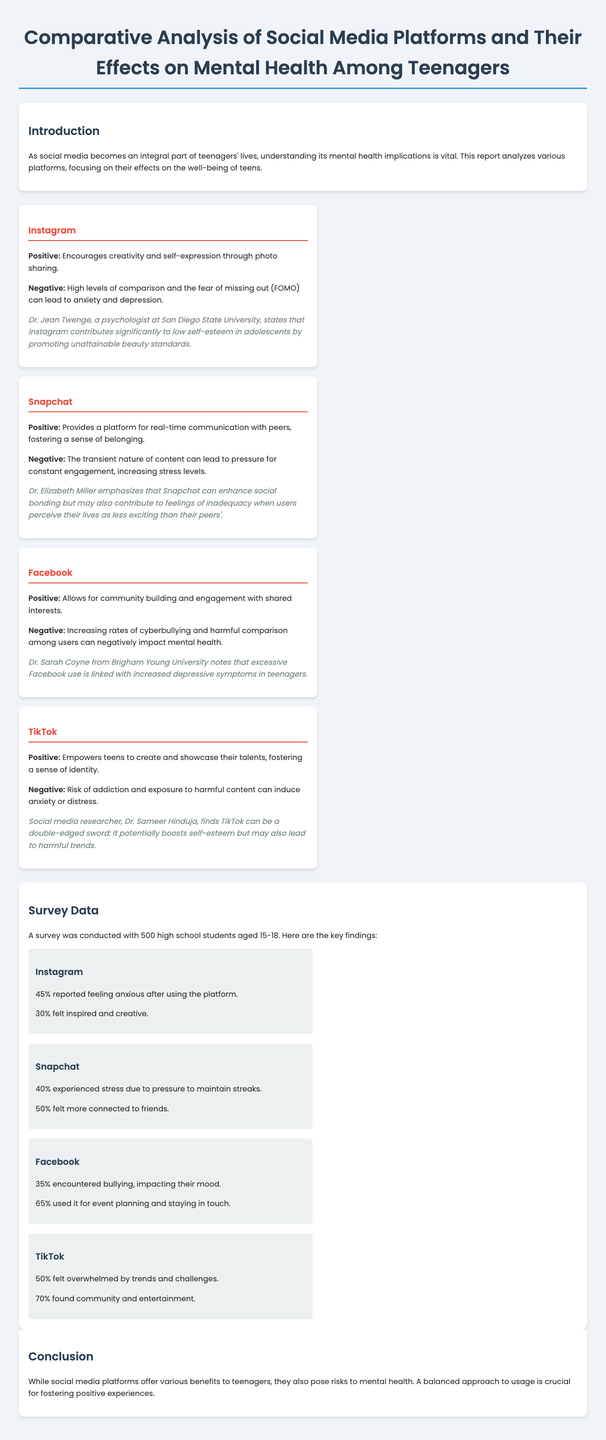what percentage of teenagers felt anxious after using Instagram? The document states that 45% of teenagers reported feeling anxious after using Instagram.
Answer: 45% what is a positive aspect of Snapchat mentioned in the report? The report highlights that Snapchat provides a platform for real-time communication with peers, fostering a sense of belonging.
Answer: Real-time communication who conducted the survey mentioned in the document? The document does not specify an individual or organization conducting the survey, it simply states that a survey was conducted with high school students.
Answer: Not specified what percentage of TikTok users found community and entertainment? According to the survey data, 70% of TikTok users found community and entertainment through the platform.
Answer: 70% what is one negative effect of Facebook reported in the analysis? The report notes that Facebook has increasing rates of cyberbullying, which can impact users' mental health negatively.
Answer: Cyberbullying which expert stated that Instagram contributes to low self-esteem in adolescents? Dr. Jean Twenge is cited in the report as stating that Instagram contributes significantly to low self-esteem in adolescents.
Answer: Dr. Jean Twenge what percentage of Snapchat users felt more connected to friends? The document states that 50% of Snapchat users felt more connected to friends.
Answer: 50% what is the main conclusion drawn in the report? The conclusion emphasizes that while social media platforms provide benefits, they also pose risks to mental health and a balanced approach to usage is crucial.
Answer: Balanced approach is crucial 